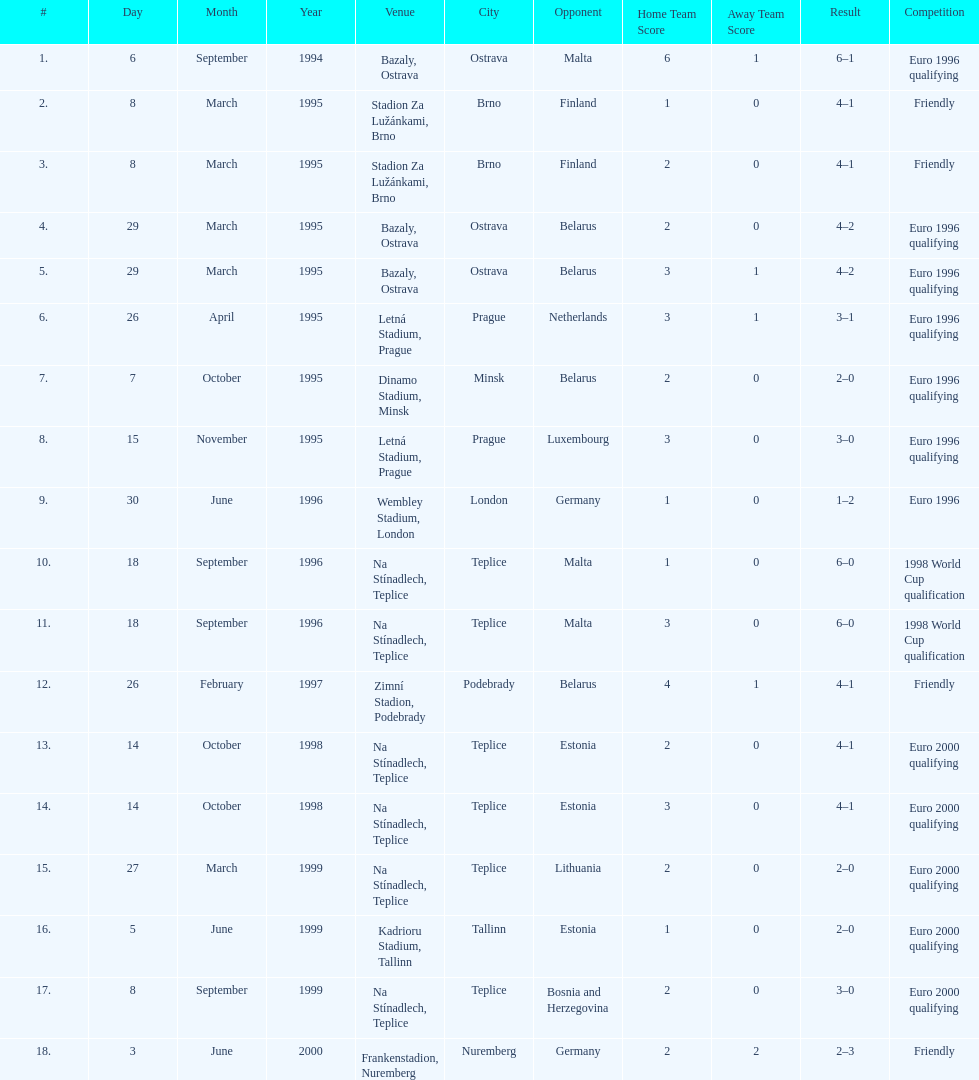Which team did czech republic score the most goals against? Malta. 